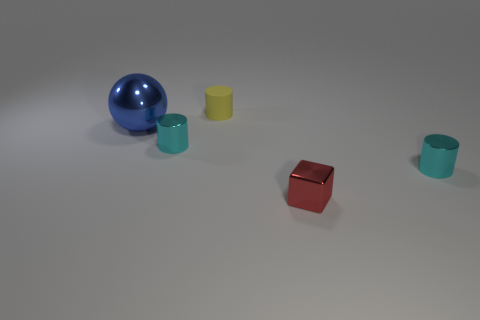What could be the purpose of these objects? These objects could be part of a visual composition exercise; they seem to represent different geometric forms and colors and could also be used for educational purposes to teach concepts of geometry, color theory, or material properties. Are there any details that suggest they might be used for teaching? The clean and simple arrangement of the objects, as well as the distinct colors and shapes, suggest an educational setup. They may be configured this way to clearly demonstrate differences in form and shade. 